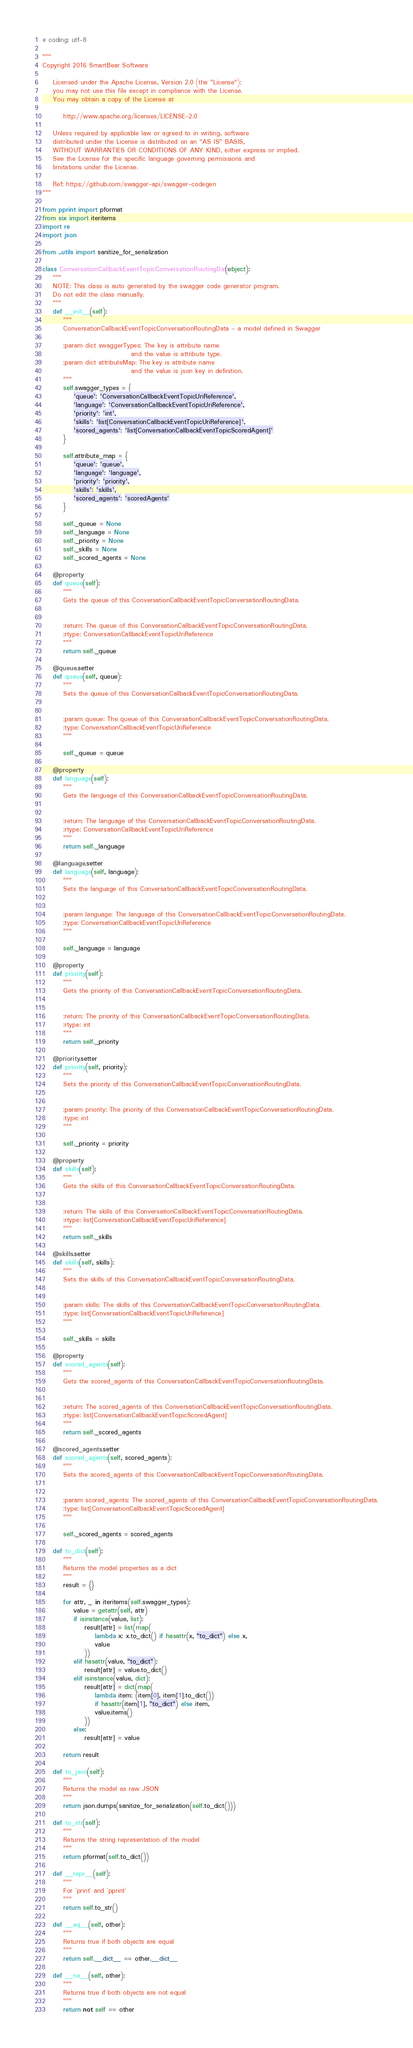Convert code to text. <code><loc_0><loc_0><loc_500><loc_500><_Python_># coding: utf-8

"""
Copyright 2016 SmartBear Software

    Licensed under the Apache License, Version 2.0 (the "License");
    you may not use this file except in compliance with the License.
    You may obtain a copy of the License at

        http://www.apache.org/licenses/LICENSE-2.0

    Unless required by applicable law or agreed to in writing, software
    distributed under the License is distributed on an "AS IS" BASIS,
    WITHOUT WARRANTIES OR CONDITIONS OF ANY KIND, either express or implied.
    See the License for the specific language governing permissions and
    limitations under the License.

    Ref: https://github.com/swagger-api/swagger-codegen
"""

from pprint import pformat
from six import iteritems
import re
import json

from ..utils import sanitize_for_serialization

class ConversationCallbackEventTopicConversationRoutingData(object):
    """
    NOTE: This class is auto generated by the swagger code generator program.
    Do not edit the class manually.
    """
    def __init__(self):
        """
        ConversationCallbackEventTopicConversationRoutingData - a model defined in Swagger

        :param dict swaggerTypes: The key is attribute name
                                  and the value is attribute type.
        :param dict attributeMap: The key is attribute name
                                  and the value is json key in definition.
        """
        self.swagger_types = {
            'queue': 'ConversationCallbackEventTopicUriReference',
            'language': 'ConversationCallbackEventTopicUriReference',
            'priority': 'int',
            'skills': 'list[ConversationCallbackEventTopicUriReference]',
            'scored_agents': 'list[ConversationCallbackEventTopicScoredAgent]'
        }

        self.attribute_map = {
            'queue': 'queue',
            'language': 'language',
            'priority': 'priority',
            'skills': 'skills',
            'scored_agents': 'scoredAgents'
        }

        self._queue = None
        self._language = None
        self._priority = None
        self._skills = None
        self._scored_agents = None

    @property
    def queue(self):
        """
        Gets the queue of this ConversationCallbackEventTopicConversationRoutingData.


        :return: The queue of this ConversationCallbackEventTopicConversationRoutingData.
        :rtype: ConversationCallbackEventTopicUriReference
        """
        return self._queue

    @queue.setter
    def queue(self, queue):
        """
        Sets the queue of this ConversationCallbackEventTopicConversationRoutingData.


        :param queue: The queue of this ConversationCallbackEventTopicConversationRoutingData.
        :type: ConversationCallbackEventTopicUriReference
        """
        
        self._queue = queue

    @property
    def language(self):
        """
        Gets the language of this ConversationCallbackEventTopicConversationRoutingData.


        :return: The language of this ConversationCallbackEventTopicConversationRoutingData.
        :rtype: ConversationCallbackEventTopicUriReference
        """
        return self._language

    @language.setter
    def language(self, language):
        """
        Sets the language of this ConversationCallbackEventTopicConversationRoutingData.


        :param language: The language of this ConversationCallbackEventTopicConversationRoutingData.
        :type: ConversationCallbackEventTopicUriReference
        """
        
        self._language = language

    @property
    def priority(self):
        """
        Gets the priority of this ConversationCallbackEventTopicConversationRoutingData.


        :return: The priority of this ConversationCallbackEventTopicConversationRoutingData.
        :rtype: int
        """
        return self._priority

    @priority.setter
    def priority(self, priority):
        """
        Sets the priority of this ConversationCallbackEventTopicConversationRoutingData.


        :param priority: The priority of this ConversationCallbackEventTopicConversationRoutingData.
        :type: int
        """
        
        self._priority = priority

    @property
    def skills(self):
        """
        Gets the skills of this ConversationCallbackEventTopicConversationRoutingData.


        :return: The skills of this ConversationCallbackEventTopicConversationRoutingData.
        :rtype: list[ConversationCallbackEventTopicUriReference]
        """
        return self._skills

    @skills.setter
    def skills(self, skills):
        """
        Sets the skills of this ConversationCallbackEventTopicConversationRoutingData.


        :param skills: The skills of this ConversationCallbackEventTopicConversationRoutingData.
        :type: list[ConversationCallbackEventTopicUriReference]
        """
        
        self._skills = skills

    @property
    def scored_agents(self):
        """
        Gets the scored_agents of this ConversationCallbackEventTopicConversationRoutingData.


        :return: The scored_agents of this ConversationCallbackEventTopicConversationRoutingData.
        :rtype: list[ConversationCallbackEventTopicScoredAgent]
        """
        return self._scored_agents

    @scored_agents.setter
    def scored_agents(self, scored_agents):
        """
        Sets the scored_agents of this ConversationCallbackEventTopicConversationRoutingData.


        :param scored_agents: The scored_agents of this ConversationCallbackEventTopicConversationRoutingData.
        :type: list[ConversationCallbackEventTopicScoredAgent]
        """
        
        self._scored_agents = scored_agents

    def to_dict(self):
        """
        Returns the model properties as a dict
        """
        result = {}

        for attr, _ in iteritems(self.swagger_types):
            value = getattr(self, attr)
            if isinstance(value, list):
                result[attr] = list(map(
                    lambda x: x.to_dict() if hasattr(x, "to_dict") else x,
                    value
                ))
            elif hasattr(value, "to_dict"):
                result[attr] = value.to_dict()
            elif isinstance(value, dict):
                result[attr] = dict(map(
                    lambda item: (item[0], item[1].to_dict())
                    if hasattr(item[1], "to_dict") else item,
                    value.items()
                ))
            else:
                result[attr] = value

        return result

    def to_json(self):
        """
        Returns the model as raw JSON
        """
        return json.dumps(sanitize_for_serialization(self.to_dict()))

    def to_str(self):
        """
        Returns the string representation of the model
        """
        return pformat(self.to_dict())

    def __repr__(self):
        """
        For `print` and `pprint`
        """
        return self.to_str()

    def __eq__(self, other):
        """
        Returns true if both objects are equal
        """
        return self.__dict__ == other.__dict__

    def __ne__(self, other):
        """
        Returns true if both objects are not equal
        """
        return not self == other

</code> 